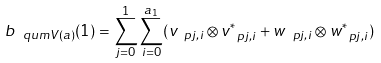Convert formula to latex. <formula><loc_0><loc_0><loc_500><loc_500>b _ { \ q u m { V } ( a ) } ( 1 ) = \sum _ { j = 0 } ^ { 1 } \sum _ { i = 0 } ^ { a _ { 1 } } ( v _ { \ p j , i } \otimes v _ { \ p j , i } ^ { * } + w _ { \ p j , i } \otimes w _ { \ p j , i } ^ { * } )</formula> 